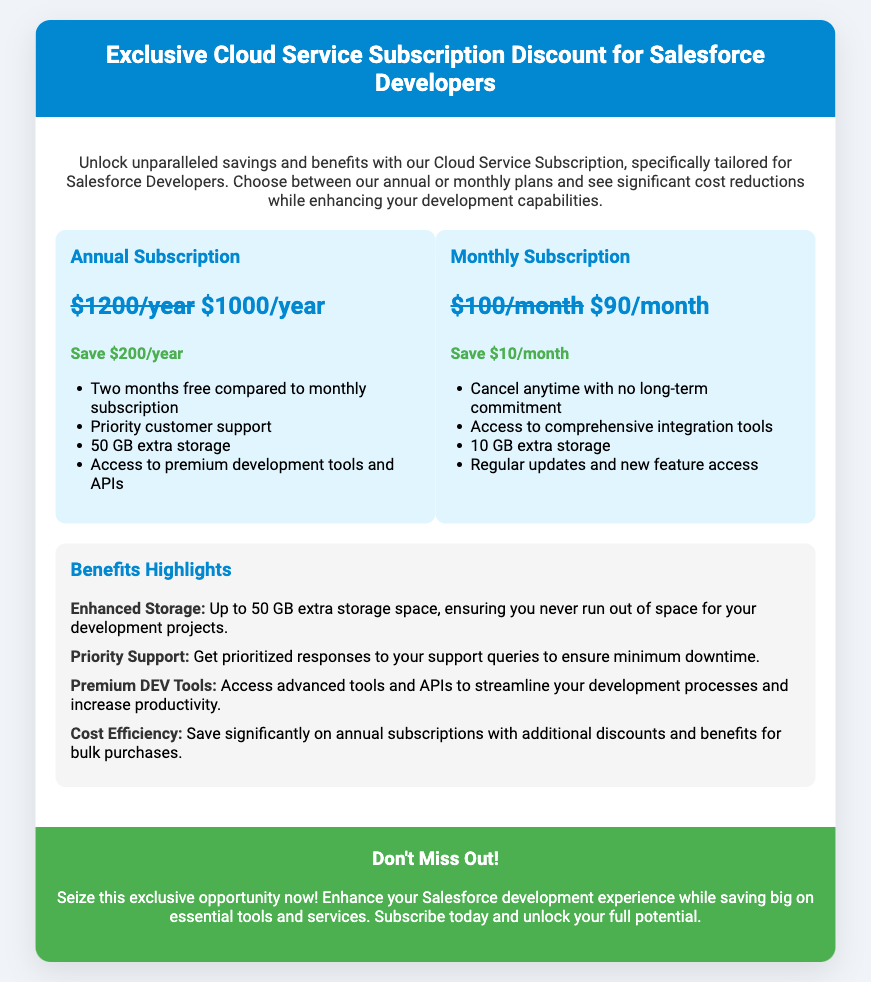What is the original price of the annual subscription? The original price of the annual subscription can be found in the discount breakdown, which states it is $1200/year.
Answer: $1200/year What is the price of the monthly subscription after the discount? The price of the monthly subscription after the discount is mentioned as $90/month.
Answer: $90/month How much can a user save by choosing the annual subscription? The savings for the annual subscription is detailed in the document as $200/year.
Answer: $200/year What are the extra storage benefits for the annual plan? The document specifies that the annual plan offers 50 GB extra storage.
Answer: 50 GB extra storage Which subscription plan allows cancellation without a long-term commitment? The monthly subscription plan includes the ability to cancel anytime with no long-term commitment.
Answer: Monthly subscription What is one of the benefits of the annual subscription regarding support? The document highlights that the annual subscription includes priority customer support.
Answer: Priority customer support How many months free does the annual subscription offer compared to the monthly plan? The discount breakdown mentions that the annual subscription provides two months free compared to the monthly plan.
Answer: Two months free What is the term used to describe the tools provided in the annual subscription? The document refers to tools and APIs as premium development tools provided with the annual subscription.
Answer: Premium development tools How long is the price validity period for the monthly subscription? The document does not specifically state a price validity period for the monthly subscription.
Answer: Not specified 